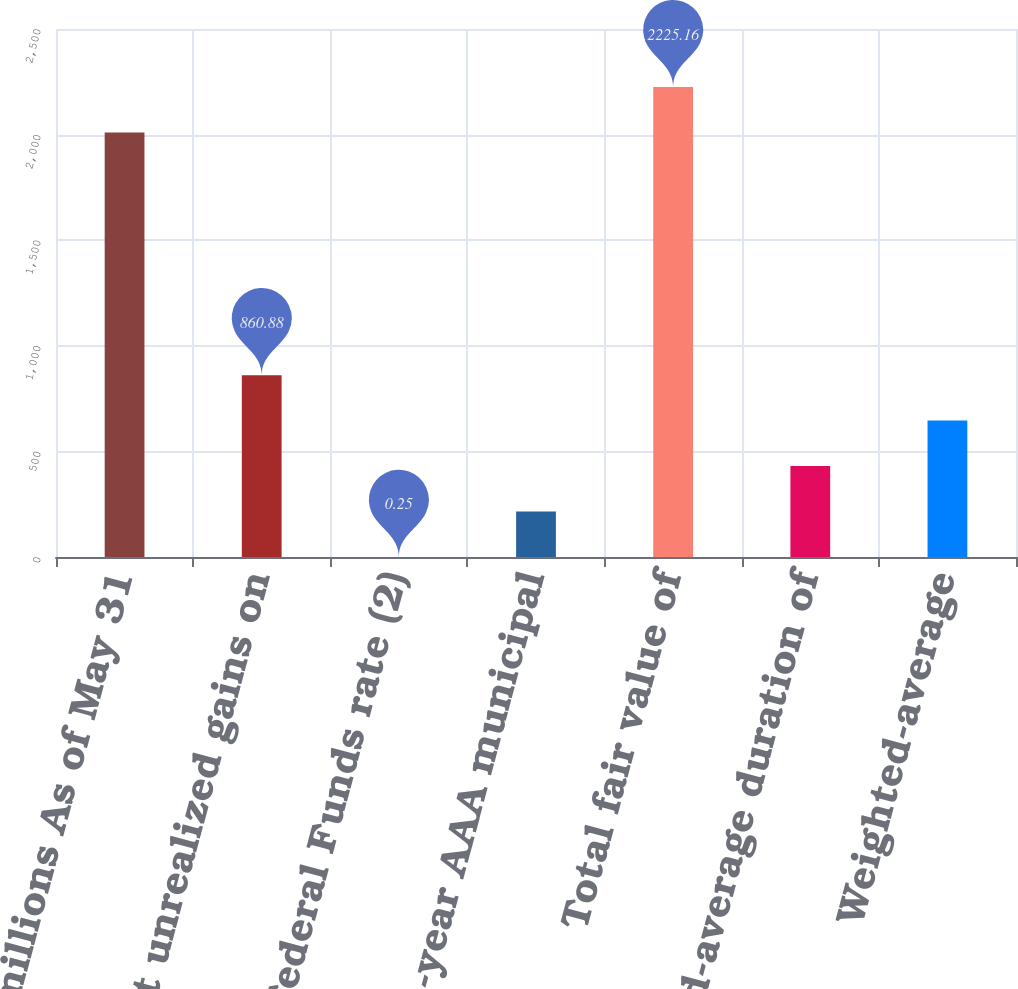Convert chart. <chart><loc_0><loc_0><loc_500><loc_500><bar_chart><fcel>in millions As of May 31<fcel>Net unrealized gains on<fcel>Federal Funds rate (2)<fcel>Three-year AAA municipal<fcel>Total fair value of<fcel>Weighted-average duration of<fcel>Weighted-average<nl><fcel>2010<fcel>860.88<fcel>0.25<fcel>215.41<fcel>2225.16<fcel>430.57<fcel>645.73<nl></chart> 